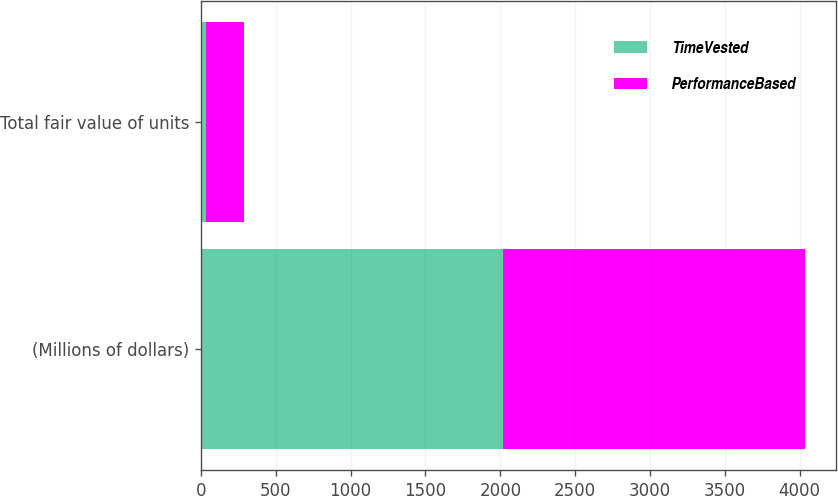Convert chart to OTSL. <chart><loc_0><loc_0><loc_500><loc_500><stacked_bar_chart><ecel><fcel>(Millions of dollars)<fcel>Total fair value of units<nl><fcel>TimeVested<fcel>2019<fcel>33<nl><fcel>PerformanceBased<fcel>2019<fcel>254<nl></chart> 